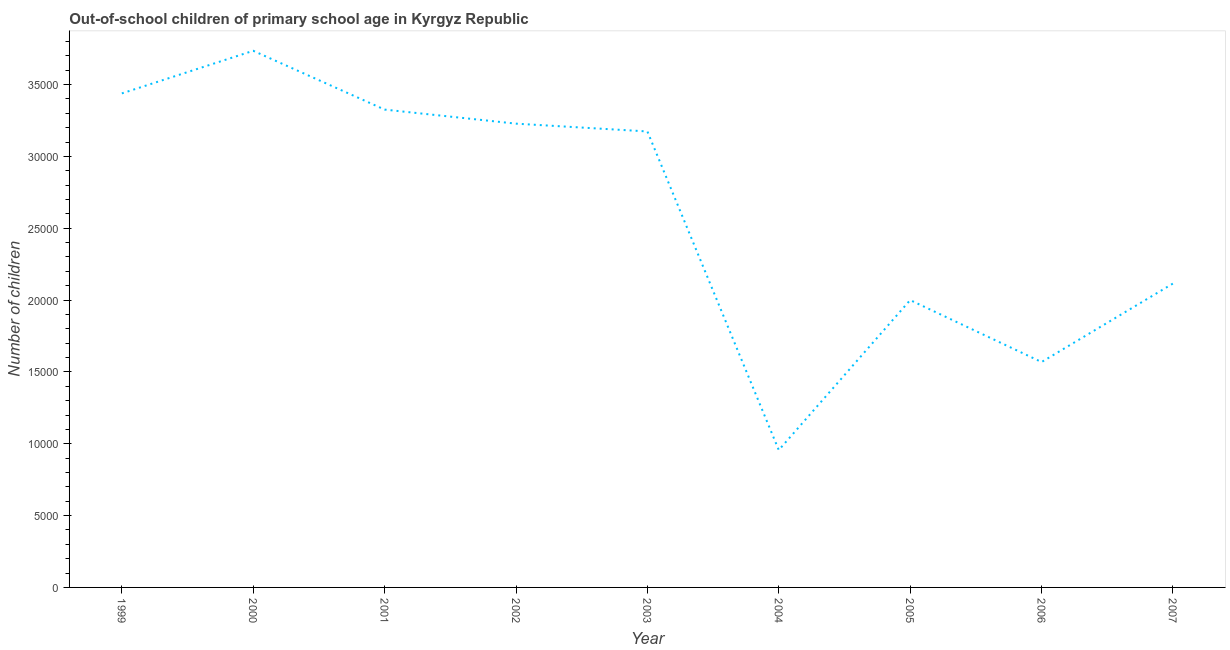What is the number of out-of-school children in 2002?
Ensure brevity in your answer.  3.23e+04. Across all years, what is the maximum number of out-of-school children?
Offer a terse response. 3.73e+04. Across all years, what is the minimum number of out-of-school children?
Your answer should be compact. 9560. In which year was the number of out-of-school children maximum?
Ensure brevity in your answer.  2000. What is the sum of the number of out-of-school children?
Your answer should be compact. 2.35e+05. What is the difference between the number of out-of-school children in 2002 and 2004?
Your response must be concise. 2.27e+04. What is the average number of out-of-school children per year?
Keep it short and to the point. 2.62e+04. What is the median number of out-of-school children?
Offer a very short reply. 3.17e+04. Do a majority of the years between 1999 and 2002 (inclusive) have number of out-of-school children greater than 25000 ?
Provide a succinct answer. Yes. What is the ratio of the number of out-of-school children in 2001 to that in 2002?
Provide a succinct answer. 1.03. Is the number of out-of-school children in 1999 less than that in 2006?
Give a very brief answer. No. Is the difference between the number of out-of-school children in 2000 and 2004 greater than the difference between any two years?
Your answer should be very brief. Yes. What is the difference between the highest and the second highest number of out-of-school children?
Ensure brevity in your answer.  2965. What is the difference between the highest and the lowest number of out-of-school children?
Ensure brevity in your answer.  2.78e+04. How many lines are there?
Provide a short and direct response. 1. Are the values on the major ticks of Y-axis written in scientific E-notation?
Your answer should be compact. No. Does the graph contain any zero values?
Make the answer very short. No. What is the title of the graph?
Give a very brief answer. Out-of-school children of primary school age in Kyrgyz Republic. What is the label or title of the X-axis?
Make the answer very short. Year. What is the label or title of the Y-axis?
Make the answer very short. Number of children. What is the Number of children of 1999?
Offer a terse response. 3.44e+04. What is the Number of children of 2000?
Make the answer very short. 3.73e+04. What is the Number of children in 2001?
Provide a short and direct response. 3.33e+04. What is the Number of children of 2002?
Ensure brevity in your answer.  3.23e+04. What is the Number of children in 2003?
Offer a terse response. 3.17e+04. What is the Number of children of 2004?
Offer a very short reply. 9560. What is the Number of children of 2005?
Your response must be concise. 2.00e+04. What is the Number of children of 2006?
Ensure brevity in your answer.  1.57e+04. What is the Number of children of 2007?
Offer a very short reply. 2.11e+04. What is the difference between the Number of children in 1999 and 2000?
Provide a short and direct response. -2965. What is the difference between the Number of children in 1999 and 2001?
Keep it short and to the point. 1127. What is the difference between the Number of children in 1999 and 2002?
Your response must be concise. 2106. What is the difference between the Number of children in 1999 and 2003?
Offer a terse response. 2649. What is the difference between the Number of children in 1999 and 2004?
Provide a succinct answer. 2.48e+04. What is the difference between the Number of children in 1999 and 2005?
Your answer should be compact. 1.44e+04. What is the difference between the Number of children in 1999 and 2006?
Offer a very short reply. 1.87e+04. What is the difference between the Number of children in 1999 and 2007?
Provide a succinct answer. 1.32e+04. What is the difference between the Number of children in 2000 and 2001?
Offer a terse response. 4092. What is the difference between the Number of children in 2000 and 2002?
Provide a short and direct response. 5071. What is the difference between the Number of children in 2000 and 2003?
Offer a terse response. 5614. What is the difference between the Number of children in 2000 and 2004?
Offer a terse response. 2.78e+04. What is the difference between the Number of children in 2000 and 2005?
Your answer should be very brief. 1.74e+04. What is the difference between the Number of children in 2000 and 2006?
Make the answer very short. 2.17e+04. What is the difference between the Number of children in 2000 and 2007?
Give a very brief answer. 1.62e+04. What is the difference between the Number of children in 2001 and 2002?
Provide a succinct answer. 979. What is the difference between the Number of children in 2001 and 2003?
Make the answer very short. 1522. What is the difference between the Number of children in 2001 and 2004?
Offer a very short reply. 2.37e+04. What is the difference between the Number of children in 2001 and 2005?
Give a very brief answer. 1.33e+04. What is the difference between the Number of children in 2001 and 2006?
Provide a short and direct response. 1.76e+04. What is the difference between the Number of children in 2001 and 2007?
Your answer should be very brief. 1.21e+04. What is the difference between the Number of children in 2002 and 2003?
Provide a succinct answer. 543. What is the difference between the Number of children in 2002 and 2004?
Keep it short and to the point. 2.27e+04. What is the difference between the Number of children in 2002 and 2005?
Offer a very short reply. 1.23e+04. What is the difference between the Number of children in 2002 and 2006?
Provide a short and direct response. 1.66e+04. What is the difference between the Number of children in 2002 and 2007?
Make the answer very short. 1.11e+04. What is the difference between the Number of children in 2003 and 2004?
Make the answer very short. 2.22e+04. What is the difference between the Number of children in 2003 and 2005?
Make the answer very short. 1.17e+04. What is the difference between the Number of children in 2003 and 2006?
Make the answer very short. 1.60e+04. What is the difference between the Number of children in 2003 and 2007?
Your answer should be compact. 1.06e+04. What is the difference between the Number of children in 2004 and 2005?
Give a very brief answer. -1.04e+04. What is the difference between the Number of children in 2004 and 2006?
Provide a short and direct response. -6126. What is the difference between the Number of children in 2004 and 2007?
Keep it short and to the point. -1.16e+04. What is the difference between the Number of children in 2005 and 2006?
Your answer should be very brief. 4311. What is the difference between the Number of children in 2005 and 2007?
Give a very brief answer. -1152. What is the difference between the Number of children in 2006 and 2007?
Make the answer very short. -5463. What is the ratio of the Number of children in 1999 to that in 2000?
Offer a very short reply. 0.92. What is the ratio of the Number of children in 1999 to that in 2001?
Provide a short and direct response. 1.03. What is the ratio of the Number of children in 1999 to that in 2002?
Provide a succinct answer. 1.06. What is the ratio of the Number of children in 1999 to that in 2003?
Give a very brief answer. 1.08. What is the ratio of the Number of children in 1999 to that in 2004?
Provide a succinct answer. 3.6. What is the ratio of the Number of children in 1999 to that in 2005?
Provide a short and direct response. 1.72. What is the ratio of the Number of children in 1999 to that in 2006?
Your response must be concise. 2.19. What is the ratio of the Number of children in 1999 to that in 2007?
Your answer should be very brief. 1.63. What is the ratio of the Number of children in 2000 to that in 2001?
Provide a succinct answer. 1.12. What is the ratio of the Number of children in 2000 to that in 2002?
Ensure brevity in your answer.  1.16. What is the ratio of the Number of children in 2000 to that in 2003?
Your response must be concise. 1.18. What is the ratio of the Number of children in 2000 to that in 2004?
Your answer should be compact. 3.91. What is the ratio of the Number of children in 2000 to that in 2005?
Offer a very short reply. 1.87. What is the ratio of the Number of children in 2000 to that in 2006?
Offer a terse response. 2.38. What is the ratio of the Number of children in 2000 to that in 2007?
Offer a very short reply. 1.77. What is the ratio of the Number of children in 2001 to that in 2002?
Your response must be concise. 1.03. What is the ratio of the Number of children in 2001 to that in 2003?
Offer a terse response. 1.05. What is the ratio of the Number of children in 2001 to that in 2004?
Make the answer very short. 3.48. What is the ratio of the Number of children in 2001 to that in 2005?
Offer a very short reply. 1.66. What is the ratio of the Number of children in 2001 to that in 2006?
Provide a succinct answer. 2.12. What is the ratio of the Number of children in 2001 to that in 2007?
Ensure brevity in your answer.  1.57. What is the ratio of the Number of children in 2002 to that in 2003?
Provide a short and direct response. 1.02. What is the ratio of the Number of children in 2002 to that in 2004?
Your answer should be compact. 3.38. What is the ratio of the Number of children in 2002 to that in 2005?
Your answer should be compact. 1.61. What is the ratio of the Number of children in 2002 to that in 2006?
Keep it short and to the point. 2.06. What is the ratio of the Number of children in 2002 to that in 2007?
Give a very brief answer. 1.53. What is the ratio of the Number of children in 2003 to that in 2004?
Offer a very short reply. 3.32. What is the ratio of the Number of children in 2003 to that in 2005?
Ensure brevity in your answer.  1.59. What is the ratio of the Number of children in 2003 to that in 2006?
Offer a terse response. 2.02. What is the ratio of the Number of children in 2003 to that in 2007?
Keep it short and to the point. 1.5. What is the ratio of the Number of children in 2004 to that in 2005?
Offer a terse response. 0.48. What is the ratio of the Number of children in 2004 to that in 2006?
Give a very brief answer. 0.61. What is the ratio of the Number of children in 2004 to that in 2007?
Offer a very short reply. 0.45. What is the ratio of the Number of children in 2005 to that in 2006?
Offer a terse response. 1.27. What is the ratio of the Number of children in 2005 to that in 2007?
Provide a short and direct response. 0.95. What is the ratio of the Number of children in 2006 to that in 2007?
Provide a short and direct response. 0.74. 